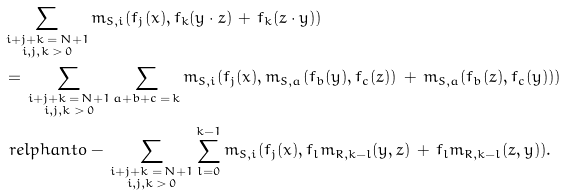<formula> <loc_0><loc_0><loc_500><loc_500>& \sum _ { \substack { i + j + k \, = \, N + 1 \\ i , j , k \, > \, 0 } } m _ { S , i } ( f _ { j } ( x ) , f _ { k } ( y \cdot z ) \, + \, f _ { k } ( z \cdot y ) ) \\ & = \, \sum _ { \substack { i + j + k \, = \, N + 1 \\ i , j , k \, > \, 0 } } \sum _ { a + b + c \, = \, k } m _ { S , i } ( f _ { j } ( x ) , m _ { S , a } ( f _ { b } ( y ) , f _ { c } ( z ) ) \, + \, m _ { S , a } ( f _ { b } ( z ) , f _ { c } ( y ) ) ) \\ & \ r e l p h a n t o - \, \sum _ { \substack { i + j + k \, = \, N + 1 \\ i , j , k \, > \, 0 } } \sum _ { l = 0 } ^ { k - 1 } m _ { S , i } ( f _ { j } ( x ) , f _ { l } m _ { R , k - l } ( y , z ) \, + \, f _ { l } m _ { R , k - l } ( z , y ) ) .</formula> 